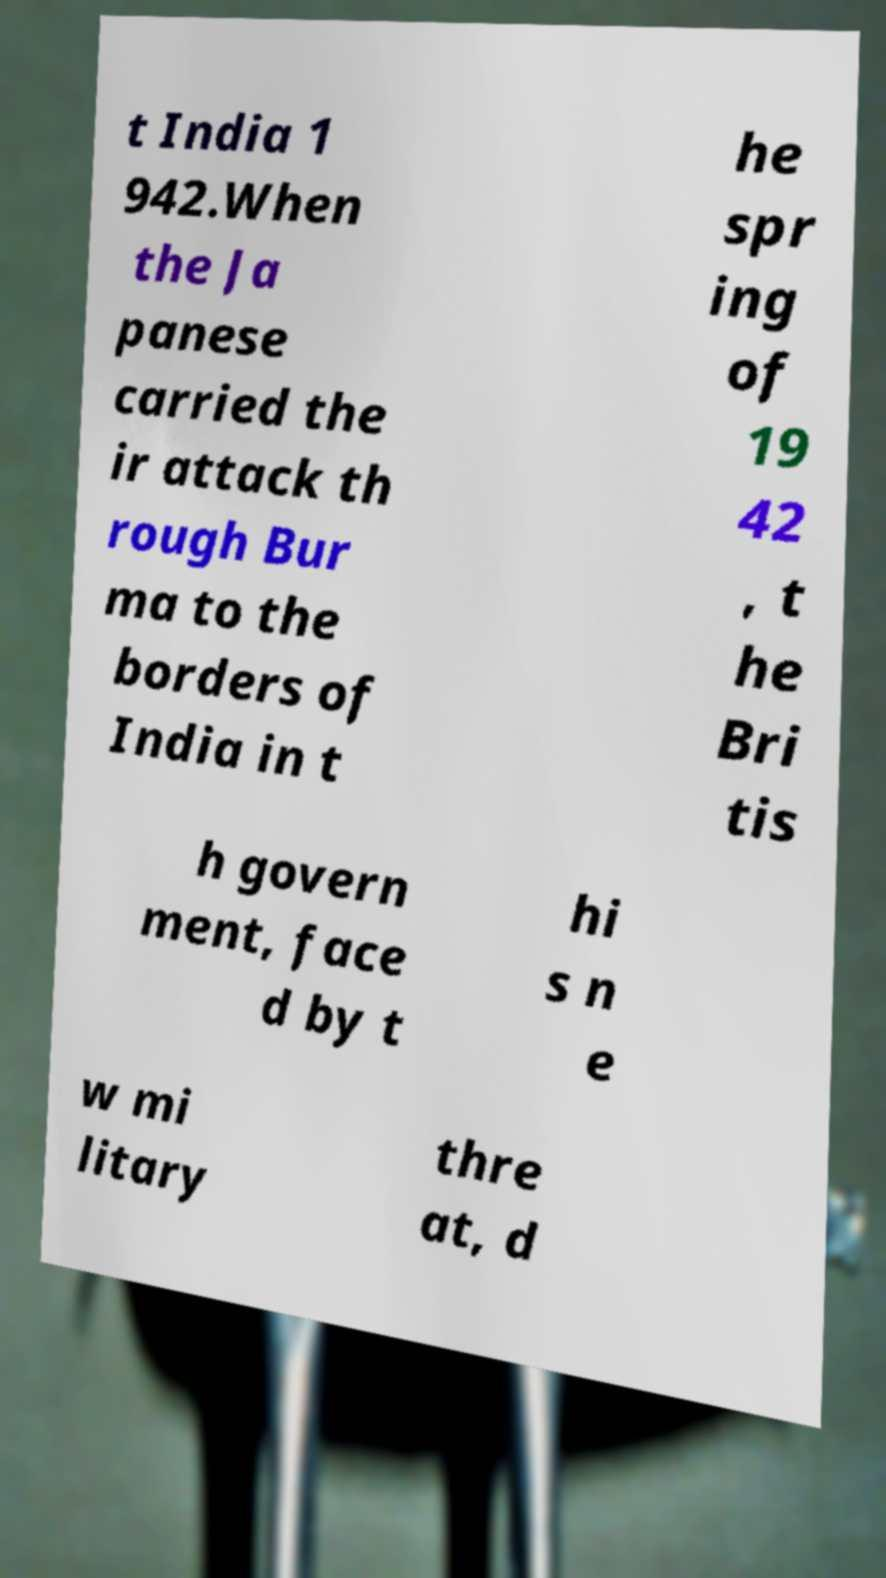Could you extract and type out the text from this image? t India 1 942.When the Ja panese carried the ir attack th rough Bur ma to the borders of India in t he spr ing of 19 42 , t he Bri tis h govern ment, face d by t hi s n e w mi litary thre at, d 